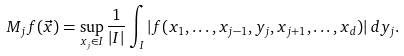Convert formula to latex. <formula><loc_0><loc_0><loc_500><loc_500>M _ { j } f ( \vec { x } ) = \sup _ { x _ { j } \in I } \frac { 1 } { | I | } \int _ { I } | f ( x _ { 1 } , \dots , x _ { j - 1 } , y _ { j } , x _ { j + 1 } , \dots , x _ { d } ) | \, d y _ { j } .</formula> 